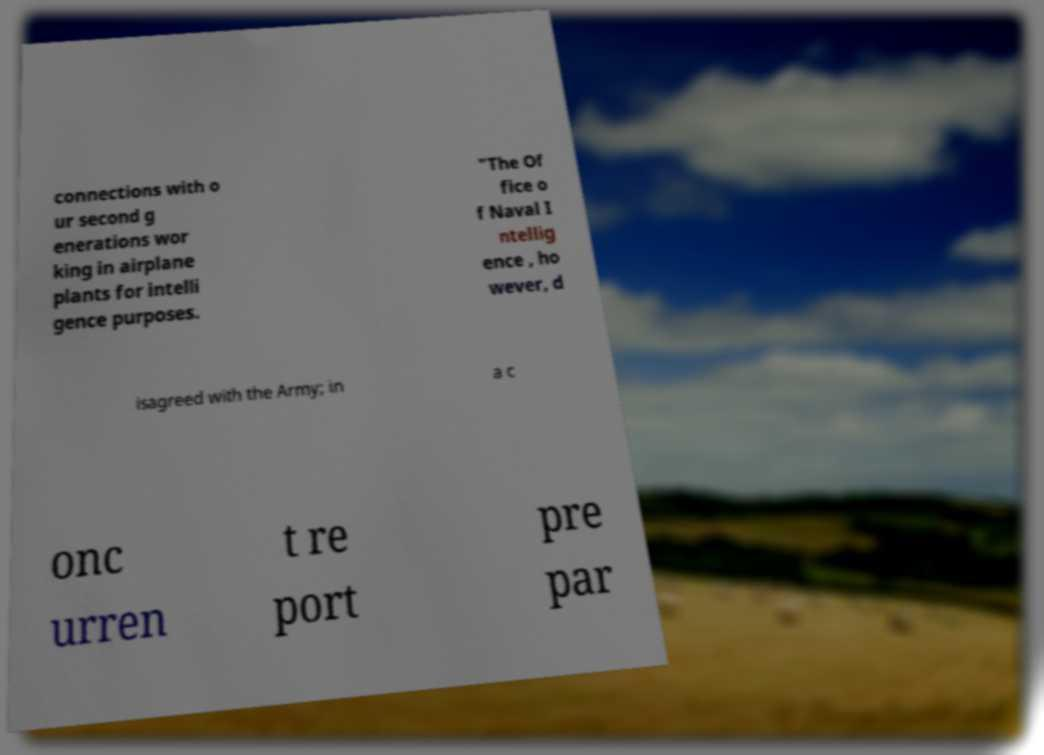I need the written content from this picture converted into text. Can you do that? connections with o ur second g enerations wor king in airplane plants for intelli gence purposes. "The Of fice o f Naval I ntellig ence , ho wever, d isagreed with the Army; in a c onc urren t re port pre par 